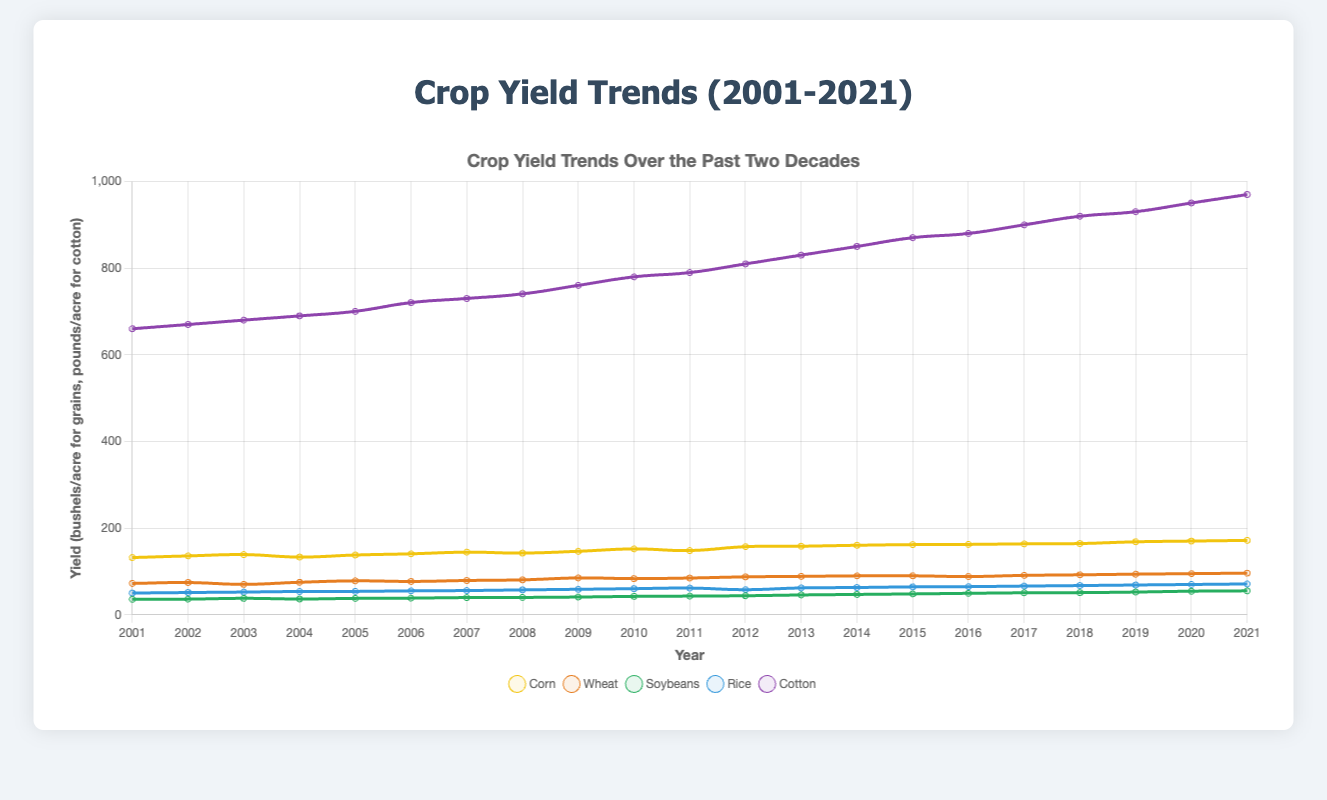What crop has the highest yield in 2021? By looking at the end of the lines for 2021, we can observe the height of each line. The purple line representing cotton is the highest, indicating cotton has the highest yield.
Answer: Cotton How did the yield of corn change from 2001 to 2021? We need to compare the values of corn for 2001 and 2021. In 2001, the yield was 132.1, and in 2021, it was 171.8. Subtracting these gives the change: 171.8 - 132.1 = 39.7
Answer: Increased by 39.7 Which year saw the largest increase in soybean yield? To find the largest increase, we need to look at the differences year-to-year for soybeans. The biggest increase is between 2019 and 2020 where the difference is 54.5 - 52.5 = 2 bushels/acre.
Answer: 2020 What color is used to represent rice in the plot? By referring to the legend, we see that the line representing rice is colored blue.
Answer: Blue Compare the yield of wheat and soybeans in 2015. Which has a higher yield? For 2015, the yield for wheat is 90.0 and for soybeans is 48.2. Comparing these two values, we find wheat has a higher yield.
Answer: Wheat Estimate the average yield of cotton over the full period 2001-2021. Find the sum of cotton yields for all given years and divide by the number of years. Sum = 660.3 + 670.1 + 680.2 + 690.0 + 700.5 + 720.7 + 730.2 + 740.8 + 760.4 + 780.1 + 790.0 + 810.0 + 830.3 + 850.3 + 870.5 + 880.3 + 900.2 + 920.0 + 930.5 + 950.6 + 970.1. Average = Sum / 21 = 17816.1 / 21 ≈ 848.4
Answer: 848.4 Which crop shows the most significant overall upward trend? Observe the slope and increases of the lines representing each crop. Cotton shows the highest upward trend from 660.3 to 970.1 over 20 years.
Answer: Cotton In what year did rice yield first exceed 60 bushels/acre? Following the blue line representing rice, we see it first exceeds 60 bushels/acre in the year 2010.
Answer: 2010 